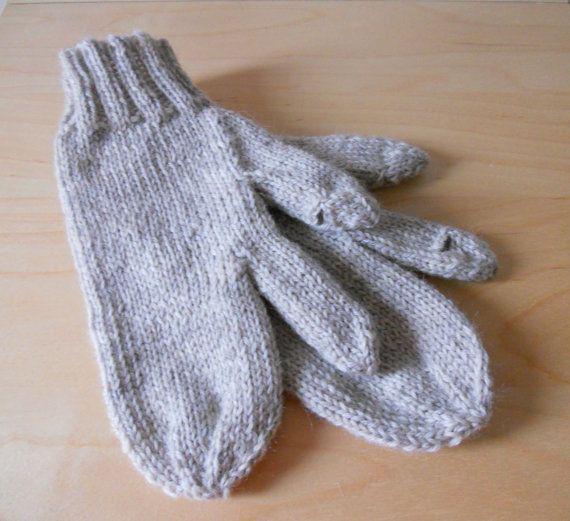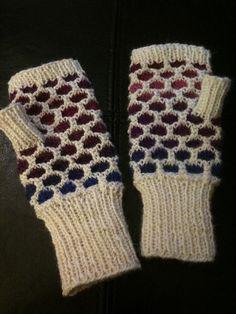The first image is the image on the left, the second image is the image on the right. Given the left and right images, does the statement "There are gloves with heart pattern shown." hold true? Answer yes or no. No. The first image is the image on the left, the second image is the image on the right. For the images displayed, is the sentence "The mittens in one of the images are lying on a wooden surface" factually correct? Answer yes or no. Yes. 